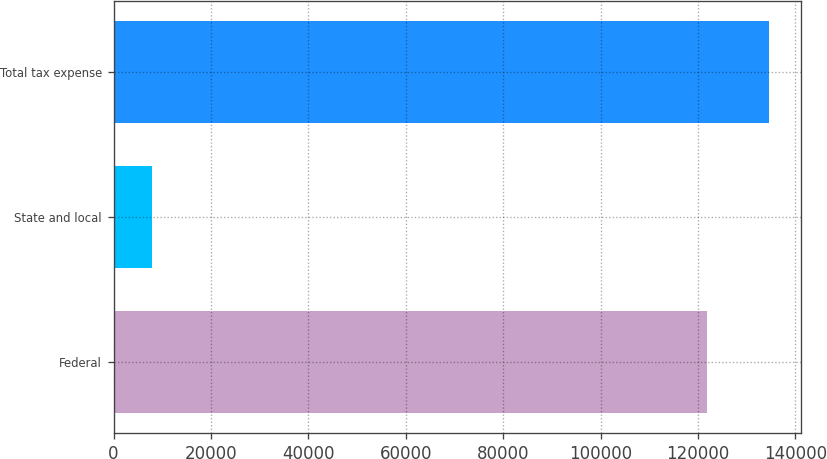Convert chart to OTSL. <chart><loc_0><loc_0><loc_500><loc_500><bar_chart><fcel>Federal<fcel>State and local<fcel>Total tax expense<nl><fcel>121855<fcel>7781<fcel>134513<nl></chart> 